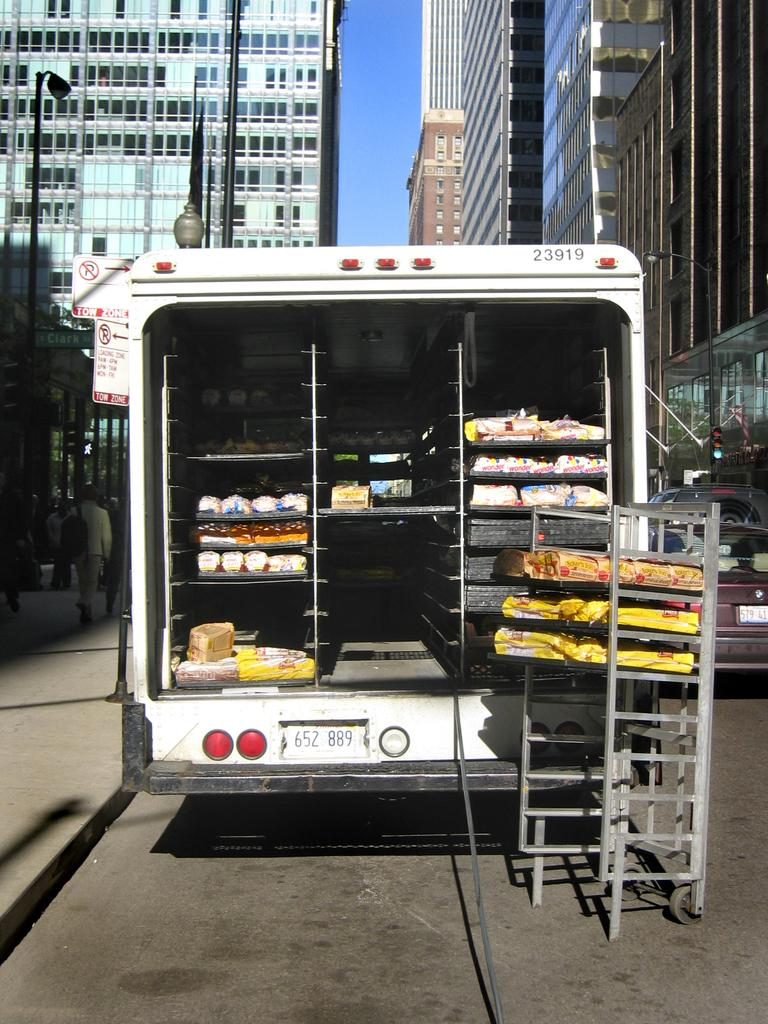What is the main subject of the image? There is a vehicle in the image. What feature does the vehicle have? The vehicle has racks. What else can be seen in the image besides the vehicle? There are poles in the image. What is visible in the background of the image? There are buildings and the sky visible in the background of the image. How many slaves are depicted in the image? There are no slaves present in the image. Is there a stream visible in the image? There is no stream visible in the image. 